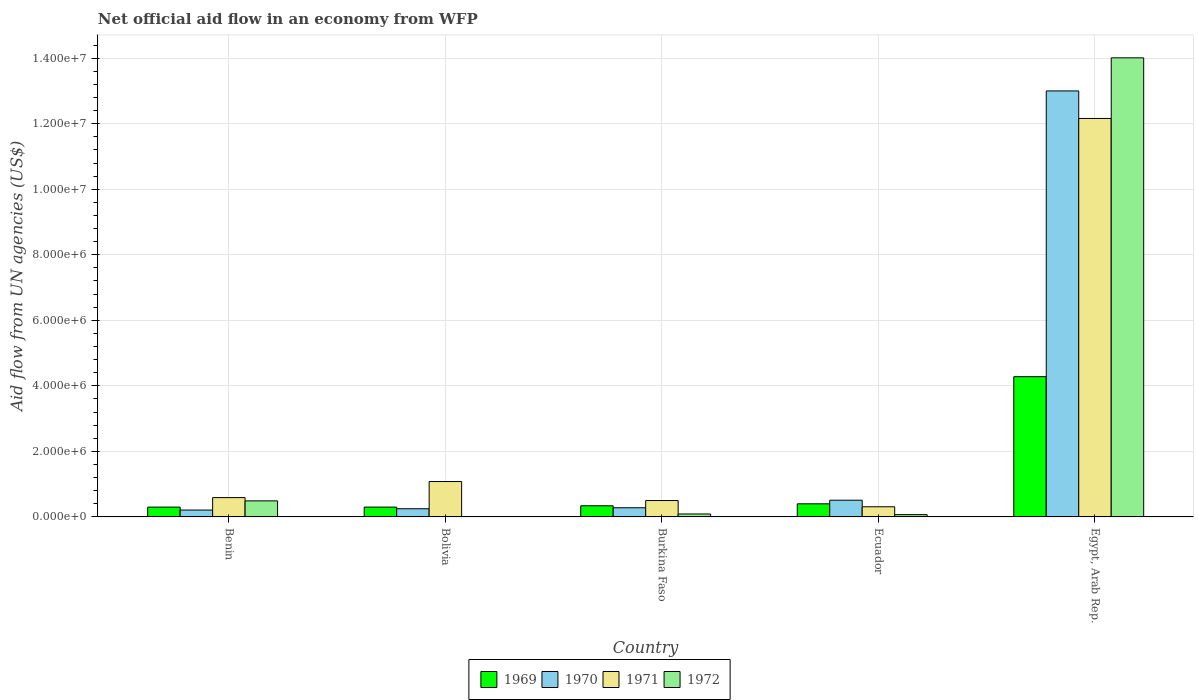How many groups of bars are there?
Provide a succinct answer. 5. Are the number of bars per tick equal to the number of legend labels?
Offer a very short reply. No. Are the number of bars on each tick of the X-axis equal?
Make the answer very short. No. How many bars are there on the 5th tick from the left?
Your answer should be very brief. 4. What is the label of the 5th group of bars from the left?
Keep it short and to the point. Egypt, Arab Rep. What is the net official aid flow in 1972 in Bolivia?
Your answer should be very brief. 0. Across all countries, what is the maximum net official aid flow in 1971?
Your answer should be very brief. 1.22e+07. In which country was the net official aid flow in 1971 maximum?
Ensure brevity in your answer.  Egypt, Arab Rep. What is the total net official aid flow in 1970 in the graph?
Offer a terse response. 1.42e+07. What is the difference between the net official aid flow in 1971 in Benin and that in Burkina Faso?
Provide a short and direct response. 9.00e+04. What is the average net official aid flow in 1972 per country?
Make the answer very short. 2.93e+06. What is the difference between the net official aid flow of/in 1971 and net official aid flow of/in 1969 in Burkina Faso?
Keep it short and to the point. 1.60e+05. What is the ratio of the net official aid flow in 1972 in Benin to that in Burkina Faso?
Provide a short and direct response. 5.44. Is the net official aid flow in 1972 in Benin less than that in Egypt, Arab Rep.?
Your answer should be compact. Yes. Is the difference between the net official aid flow in 1971 in Bolivia and Egypt, Arab Rep. greater than the difference between the net official aid flow in 1969 in Bolivia and Egypt, Arab Rep.?
Your response must be concise. No. What is the difference between the highest and the second highest net official aid flow in 1970?
Provide a succinct answer. 1.25e+07. What is the difference between the highest and the lowest net official aid flow in 1972?
Provide a succinct answer. 1.40e+07. Is the sum of the net official aid flow in 1969 in Benin and Egypt, Arab Rep. greater than the maximum net official aid flow in 1971 across all countries?
Provide a succinct answer. No. Is it the case that in every country, the sum of the net official aid flow in 1971 and net official aid flow in 1970 is greater than the sum of net official aid flow in 1969 and net official aid flow in 1972?
Offer a terse response. No. Is it the case that in every country, the sum of the net official aid flow in 1971 and net official aid flow in 1969 is greater than the net official aid flow in 1972?
Your answer should be very brief. Yes. How many bars are there?
Ensure brevity in your answer.  19. How many countries are there in the graph?
Offer a very short reply. 5. Are the values on the major ticks of Y-axis written in scientific E-notation?
Ensure brevity in your answer.  Yes. Where does the legend appear in the graph?
Offer a terse response. Bottom center. How are the legend labels stacked?
Your answer should be very brief. Horizontal. What is the title of the graph?
Your answer should be very brief. Net official aid flow in an economy from WFP. What is the label or title of the Y-axis?
Give a very brief answer. Aid flow from UN agencies (US$). What is the Aid flow from UN agencies (US$) of 1969 in Benin?
Offer a terse response. 3.00e+05. What is the Aid flow from UN agencies (US$) in 1970 in Benin?
Your response must be concise. 2.10e+05. What is the Aid flow from UN agencies (US$) of 1971 in Benin?
Make the answer very short. 5.90e+05. What is the Aid flow from UN agencies (US$) of 1972 in Benin?
Give a very brief answer. 4.90e+05. What is the Aid flow from UN agencies (US$) of 1969 in Bolivia?
Give a very brief answer. 3.00e+05. What is the Aid flow from UN agencies (US$) of 1971 in Bolivia?
Offer a very short reply. 1.08e+06. What is the Aid flow from UN agencies (US$) of 1972 in Bolivia?
Keep it short and to the point. 0. What is the Aid flow from UN agencies (US$) of 1969 in Burkina Faso?
Give a very brief answer. 3.40e+05. What is the Aid flow from UN agencies (US$) in 1970 in Burkina Faso?
Ensure brevity in your answer.  2.80e+05. What is the Aid flow from UN agencies (US$) in 1972 in Burkina Faso?
Give a very brief answer. 9.00e+04. What is the Aid flow from UN agencies (US$) of 1969 in Ecuador?
Give a very brief answer. 4.00e+05. What is the Aid flow from UN agencies (US$) of 1970 in Ecuador?
Offer a terse response. 5.10e+05. What is the Aid flow from UN agencies (US$) in 1971 in Ecuador?
Your response must be concise. 3.10e+05. What is the Aid flow from UN agencies (US$) of 1972 in Ecuador?
Provide a short and direct response. 7.00e+04. What is the Aid flow from UN agencies (US$) in 1969 in Egypt, Arab Rep.?
Make the answer very short. 4.28e+06. What is the Aid flow from UN agencies (US$) in 1970 in Egypt, Arab Rep.?
Make the answer very short. 1.30e+07. What is the Aid flow from UN agencies (US$) of 1971 in Egypt, Arab Rep.?
Your response must be concise. 1.22e+07. What is the Aid flow from UN agencies (US$) of 1972 in Egypt, Arab Rep.?
Give a very brief answer. 1.40e+07. Across all countries, what is the maximum Aid flow from UN agencies (US$) in 1969?
Ensure brevity in your answer.  4.28e+06. Across all countries, what is the maximum Aid flow from UN agencies (US$) of 1970?
Provide a short and direct response. 1.30e+07. Across all countries, what is the maximum Aid flow from UN agencies (US$) in 1971?
Offer a very short reply. 1.22e+07. Across all countries, what is the maximum Aid flow from UN agencies (US$) of 1972?
Provide a succinct answer. 1.40e+07. Across all countries, what is the minimum Aid flow from UN agencies (US$) in 1972?
Ensure brevity in your answer.  0. What is the total Aid flow from UN agencies (US$) of 1969 in the graph?
Provide a short and direct response. 5.62e+06. What is the total Aid flow from UN agencies (US$) in 1970 in the graph?
Ensure brevity in your answer.  1.42e+07. What is the total Aid flow from UN agencies (US$) of 1971 in the graph?
Your response must be concise. 1.46e+07. What is the total Aid flow from UN agencies (US$) of 1972 in the graph?
Offer a terse response. 1.47e+07. What is the difference between the Aid flow from UN agencies (US$) in 1971 in Benin and that in Bolivia?
Offer a terse response. -4.90e+05. What is the difference between the Aid flow from UN agencies (US$) of 1969 in Benin and that in Burkina Faso?
Offer a very short reply. -4.00e+04. What is the difference between the Aid flow from UN agencies (US$) in 1971 in Benin and that in Burkina Faso?
Ensure brevity in your answer.  9.00e+04. What is the difference between the Aid flow from UN agencies (US$) of 1972 in Benin and that in Burkina Faso?
Give a very brief answer. 4.00e+05. What is the difference between the Aid flow from UN agencies (US$) in 1969 in Benin and that in Egypt, Arab Rep.?
Your answer should be very brief. -3.98e+06. What is the difference between the Aid flow from UN agencies (US$) in 1970 in Benin and that in Egypt, Arab Rep.?
Give a very brief answer. -1.28e+07. What is the difference between the Aid flow from UN agencies (US$) of 1971 in Benin and that in Egypt, Arab Rep.?
Provide a short and direct response. -1.16e+07. What is the difference between the Aid flow from UN agencies (US$) of 1972 in Benin and that in Egypt, Arab Rep.?
Provide a short and direct response. -1.35e+07. What is the difference between the Aid flow from UN agencies (US$) of 1969 in Bolivia and that in Burkina Faso?
Your answer should be very brief. -4.00e+04. What is the difference between the Aid flow from UN agencies (US$) of 1971 in Bolivia and that in Burkina Faso?
Provide a succinct answer. 5.80e+05. What is the difference between the Aid flow from UN agencies (US$) in 1969 in Bolivia and that in Ecuador?
Your answer should be compact. -1.00e+05. What is the difference between the Aid flow from UN agencies (US$) in 1970 in Bolivia and that in Ecuador?
Provide a short and direct response. -2.60e+05. What is the difference between the Aid flow from UN agencies (US$) in 1971 in Bolivia and that in Ecuador?
Make the answer very short. 7.70e+05. What is the difference between the Aid flow from UN agencies (US$) in 1969 in Bolivia and that in Egypt, Arab Rep.?
Provide a short and direct response. -3.98e+06. What is the difference between the Aid flow from UN agencies (US$) of 1970 in Bolivia and that in Egypt, Arab Rep.?
Provide a succinct answer. -1.28e+07. What is the difference between the Aid flow from UN agencies (US$) of 1971 in Bolivia and that in Egypt, Arab Rep.?
Offer a very short reply. -1.11e+07. What is the difference between the Aid flow from UN agencies (US$) of 1970 in Burkina Faso and that in Ecuador?
Ensure brevity in your answer.  -2.30e+05. What is the difference between the Aid flow from UN agencies (US$) in 1971 in Burkina Faso and that in Ecuador?
Keep it short and to the point. 1.90e+05. What is the difference between the Aid flow from UN agencies (US$) of 1972 in Burkina Faso and that in Ecuador?
Ensure brevity in your answer.  2.00e+04. What is the difference between the Aid flow from UN agencies (US$) in 1969 in Burkina Faso and that in Egypt, Arab Rep.?
Your response must be concise. -3.94e+06. What is the difference between the Aid flow from UN agencies (US$) in 1970 in Burkina Faso and that in Egypt, Arab Rep.?
Provide a short and direct response. -1.27e+07. What is the difference between the Aid flow from UN agencies (US$) in 1971 in Burkina Faso and that in Egypt, Arab Rep.?
Give a very brief answer. -1.17e+07. What is the difference between the Aid flow from UN agencies (US$) of 1972 in Burkina Faso and that in Egypt, Arab Rep.?
Your answer should be very brief. -1.39e+07. What is the difference between the Aid flow from UN agencies (US$) of 1969 in Ecuador and that in Egypt, Arab Rep.?
Provide a short and direct response. -3.88e+06. What is the difference between the Aid flow from UN agencies (US$) in 1970 in Ecuador and that in Egypt, Arab Rep.?
Offer a terse response. -1.25e+07. What is the difference between the Aid flow from UN agencies (US$) of 1971 in Ecuador and that in Egypt, Arab Rep.?
Your answer should be very brief. -1.18e+07. What is the difference between the Aid flow from UN agencies (US$) in 1972 in Ecuador and that in Egypt, Arab Rep.?
Provide a short and direct response. -1.39e+07. What is the difference between the Aid flow from UN agencies (US$) of 1969 in Benin and the Aid flow from UN agencies (US$) of 1970 in Bolivia?
Your response must be concise. 5.00e+04. What is the difference between the Aid flow from UN agencies (US$) of 1969 in Benin and the Aid flow from UN agencies (US$) of 1971 in Bolivia?
Provide a succinct answer. -7.80e+05. What is the difference between the Aid flow from UN agencies (US$) in 1970 in Benin and the Aid flow from UN agencies (US$) in 1971 in Bolivia?
Your response must be concise. -8.70e+05. What is the difference between the Aid flow from UN agencies (US$) of 1969 in Benin and the Aid flow from UN agencies (US$) of 1971 in Burkina Faso?
Your answer should be compact. -2.00e+05. What is the difference between the Aid flow from UN agencies (US$) of 1970 in Benin and the Aid flow from UN agencies (US$) of 1971 in Burkina Faso?
Ensure brevity in your answer.  -2.90e+05. What is the difference between the Aid flow from UN agencies (US$) in 1971 in Benin and the Aid flow from UN agencies (US$) in 1972 in Burkina Faso?
Ensure brevity in your answer.  5.00e+05. What is the difference between the Aid flow from UN agencies (US$) in 1969 in Benin and the Aid flow from UN agencies (US$) in 1970 in Ecuador?
Offer a very short reply. -2.10e+05. What is the difference between the Aid flow from UN agencies (US$) in 1970 in Benin and the Aid flow from UN agencies (US$) in 1972 in Ecuador?
Make the answer very short. 1.40e+05. What is the difference between the Aid flow from UN agencies (US$) of 1971 in Benin and the Aid flow from UN agencies (US$) of 1972 in Ecuador?
Keep it short and to the point. 5.20e+05. What is the difference between the Aid flow from UN agencies (US$) in 1969 in Benin and the Aid flow from UN agencies (US$) in 1970 in Egypt, Arab Rep.?
Your answer should be very brief. -1.27e+07. What is the difference between the Aid flow from UN agencies (US$) in 1969 in Benin and the Aid flow from UN agencies (US$) in 1971 in Egypt, Arab Rep.?
Offer a terse response. -1.19e+07. What is the difference between the Aid flow from UN agencies (US$) of 1969 in Benin and the Aid flow from UN agencies (US$) of 1972 in Egypt, Arab Rep.?
Offer a very short reply. -1.37e+07. What is the difference between the Aid flow from UN agencies (US$) in 1970 in Benin and the Aid flow from UN agencies (US$) in 1971 in Egypt, Arab Rep.?
Make the answer very short. -1.20e+07. What is the difference between the Aid flow from UN agencies (US$) of 1970 in Benin and the Aid flow from UN agencies (US$) of 1972 in Egypt, Arab Rep.?
Offer a terse response. -1.38e+07. What is the difference between the Aid flow from UN agencies (US$) of 1971 in Benin and the Aid flow from UN agencies (US$) of 1972 in Egypt, Arab Rep.?
Provide a succinct answer. -1.34e+07. What is the difference between the Aid flow from UN agencies (US$) of 1969 in Bolivia and the Aid flow from UN agencies (US$) of 1971 in Burkina Faso?
Keep it short and to the point. -2.00e+05. What is the difference between the Aid flow from UN agencies (US$) of 1970 in Bolivia and the Aid flow from UN agencies (US$) of 1972 in Burkina Faso?
Offer a very short reply. 1.60e+05. What is the difference between the Aid flow from UN agencies (US$) of 1971 in Bolivia and the Aid flow from UN agencies (US$) of 1972 in Burkina Faso?
Keep it short and to the point. 9.90e+05. What is the difference between the Aid flow from UN agencies (US$) of 1969 in Bolivia and the Aid flow from UN agencies (US$) of 1972 in Ecuador?
Give a very brief answer. 2.30e+05. What is the difference between the Aid flow from UN agencies (US$) of 1970 in Bolivia and the Aid flow from UN agencies (US$) of 1972 in Ecuador?
Make the answer very short. 1.80e+05. What is the difference between the Aid flow from UN agencies (US$) of 1971 in Bolivia and the Aid flow from UN agencies (US$) of 1972 in Ecuador?
Make the answer very short. 1.01e+06. What is the difference between the Aid flow from UN agencies (US$) in 1969 in Bolivia and the Aid flow from UN agencies (US$) in 1970 in Egypt, Arab Rep.?
Ensure brevity in your answer.  -1.27e+07. What is the difference between the Aid flow from UN agencies (US$) of 1969 in Bolivia and the Aid flow from UN agencies (US$) of 1971 in Egypt, Arab Rep.?
Offer a very short reply. -1.19e+07. What is the difference between the Aid flow from UN agencies (US$) of 1969 in Bolivia and the Aid flow from UN agencies (US$) of 1972 in Egypt, Arab Rep.?
Your answer should be compact. -1.37e+07. What is the difference between the Aid flow from UN agencies (US$) of 1970 in Bolivia and the Aid flow from UN agencies (US$) of 1971 in Egypt, Arab Rep.?
Ensure brevity in your answer.  -1.19e+07. What is the difference between the Aid flow from UN agencies (US$) in 1970 in Bolivia and the Aid flow from UN agencies (US$) in 1972 in Egypt, Arab Rep.?
Make the answer very short. -1.38e+07. What is the difference between the Aid flow from UN agencies (US$) of 1971 in Bolivia and the Aid flow from UN agencies (US$) of 1972 in Egypt, Arab Rep.?
Your answer should be compact. -1.29e+07. What is the difference between the Aid flow from UN agencies (US$) in 1969 in Burkina Faso and the Aid flow from UN agencies (US$) in 1970 in Ecuador?
Provide a succinct answer. -1.70e+05. What is the difference between the Aid flow from UN agencies (US$) of 1969 in Burkina Faso and the Aid flow from UN agencies (US$) of 1972 in Ecuador?
Ensure brevity in your answer.  2.70e+05. What is the difference between the Aid flow from UN agencies (US$) in 1970 in Burkina Faso and the Aid flow from UN agencies (US$) in 1971 in Ecuador?
Make the answer very short. -3.00e+04. What is the difference between the Aid flow from UN agencies (US$) of 1971 in Burkina Faso and the Aid flow from UN agencies (US$) of 1972 in Ecuador?
Offer a very short reply. 4.30e+05. What is the difference between the Aid flow from UN agencies (US$) of 1969 in Burkina Faso and the Aid flow from UN agencies (US$) of 1970 in Egypt, Arab Rep.?
Offer a very short reply. -1.27e+07. What is the difference between the Aid flow from UN agencies (US$) in 1969 in Burkina Faso and the Aid flow from UN agencies (US$) in 1971 in Egypt, Arab Rep.?
Your response must be concise. -1.18e+07. What is the difference between the Aid flow from UN agencies (US$) of 1969 in Burkina Faso and the Aid flow from UN agencies (US$) of 1972 in Egypt, Arab Rep.?
Give a very brief answer. -1.37e+07. What is the difference between the Aid flow from UN agencies (US$) in 1970 in Burkina Faso and the Aid flow from UN agencies (US$) in 1971 in Egypt, Arab Rep.?
Ensure brevity in your answer.  -1.19e+07. What is the difference between the Aid flow from UN agencies (US$) in 1970 in Burkina Faso and the Aid flow from UN agencies (US$) in 1972 in Egypt, Arab Rep.?
Ensure brevity in your answer.  -1.37e+07. What is the difference between the Aid flow from UN agencies (US$) of 1971 in Burkina Faso and the Aid flow from UN agencies (US$) of 1972 in Egypt, Arab Rep.?
Your response must be concise. -1.35e+07. What is the difference between the Aid flow from UN agencies (US$) in 1969 in Ecuador and the Aid flow from UN agencies (US$) in 1970 in Egypt, Arab Rep.?
Your response must be concise. -1.26e+07. What is the difference between the Aid flow from UN agencies (US$) of 1969 in Ecuador and the Aid flow from UN agencies (US$) of 1971 in Egypt, Arab Rep.?
Your answer should be very brief. -1.18e+07. What is the difference between the Aid flow from UN agencies (US$) in 1969 in Ecuador and the Aid flow from UN agencies (US$) in 1972 in Egypt, Arab Rep.?
Your answer should be compact. -1.36e+07. What is the difference between the Aid flow from UN agencies (US$) of 1970 in Ecuador and the Aid flow from UN agencies (US$) of 1971 in Egypt, Arab Rep.?
Make the answer very short. -1.16e+07. What is the difference between the Aid flow from UN agencies (US$) of 1970 in Ecuador and the Aid flow from UN agencies (US$) of 1972 in Egypt, Arab Rep.?
Make the answer very short. -1.35e+07. What is the difference between the Aid flow from UN agencies (US$) of 1971 in Ecuador and the Aid flow from UN agencies (US$) of 1972 in Egypt, Arab Rep.?
Provide a succinct answer. -1.37e+07. What is the average Aid flow from UN agencies (US$) in 1969 per country?
Your answer should be compact. 1.12e+06. What is the average Aid flow from UN agencies (US$) in 1970 per country?
Your response must be concise. 2.85e+06. What is the average Aid flow from UN agencies (US$) in 1971 per country?
Your answer should be very brief. 2.93e+06. What is the average Aid flow from UN agencies (US$) of 1972 per country?
Your answer should be very brief. 2.93e+06. What is the difference between the Aid flow from UN agencies (US$) of 1969 and Aid flow from UN agencies (US$) of 1970 in Benin?
Your response must be concise. 9.00e+04. What is the difference between the Aid flow from UN agencies (US$) of 1970 and Aid flow from UN agencies (US$) of 1971 in Benin?
Make the answer very short. -3.80e+05. What is the difference between the Aid flow from UN agencies (US$) of 1970 and Aid flow from UN agencies (US$) of 1972 in Benin?
Keep it short and to the point. -2.80e+05. What is the difference between the Aid flow from UN agencies (US$) of 1969 and Aid flow from UN agencies (US$) of 1971 in Bolivia?
Offer a very short reply. -7.80e+05. What is the difference between the Aid flow from UN agencies (US$) in 1970 and Aid flow from UN agencies (US$) in 1971 in Bolivia?
Your answer should be compact. -8.30e+05. What is the difference between the Aid flow from UN agencies (US$) in 1969 and Aid flow from UN agencies (US$) in 1970 in Burkina Faso?
Your response must be concise. 6.00e+04. What is the difference between the Aid flow from UN agencies (US$) of 1969 and Aid flow from UN agencies (US$) of 1972 in Burkina Faso?
Your answer should be compact. 2.50e+05. What is the difference between the Aid flow from UN agencies (US$) in 1970 and Aid flow from UN agencies (US$) in 1971 in Burkina Faso?
Offer a terse response. -2.20e+05. What is the difference between the Aid flow from UN agencies (US$) of 1970 and Aid flow from UN agencies (US$) of 1972 in Burkina Faso?
Provide a succinct answer. 1.90e+05. What is the difference between the Aid flow from UN agencies (US$) in 1970 and Aid flow from UN agencies (US$) in 1971 in Ecuador?
Your answer should be compact. 2.00e+05. What is the difference between the Aid flow from UN agencies (US$) in 1969 and Aid flow from UN agencies (US$) in 1970 in Egypt, Arab Rep.?
Give a very brief answer. -8.72e+06. What is the difference between the Aid flow from UN agencies (US$) in 1969 and Aid flow from UN agencies (US$) in 1971 in Egypt, Arab Rep.?
Give a very brief answer. -7.88e+06. What is the difference between the Aid flow from UN agencies (US$) in 1969 and Aid flow from UN agencies (US$) in 1972 in Egypt, Arab Rep.?
Your answer should be very brief. -9.73e+06. What is the difference between the Aid flow from UN agencies (US$) in 1970 and Aid flow from UN agencies (US$) in 1971 in Egypt, Arab Rep.?
Give a very brief answer. 8.40e+05. What is the difference between the Aid flow from UN agencies (US$) of 1970 and Aid flow from UN agencies (US$) of 1972 in Egypt, Arab Rep.?
Your answer should be compact. -1.01e+06. What is the difference between the Aid flow from UN agencies (US$) in 1971 and Aid flow from UN agencies (US$) in 1972 in Egypt, Arab Rep.?
Provide a succinct answer. -1.85e+06. What is the ratio of the Aid flow from UN agencies (US$) in 1969 in Benin to that in Bolivia?
Your answer should be very brief. 1. What is the ratio of the Aid flow from UN agencies (US$) in 1970 in Benin to that in Bolivia?
Keep it short and to the point. 0.84. What is the ratio of the Aid flow from UN agencies (US$) of 1971 in Benin to that in Bolivia?
Give a very brief answer. 0.55. What is the ratio of the Aid flow from UN agencies (US$) of 1969 in Benin to that in Burkina Faso?
Offer a terse response. 0.88. What is the ratio of the Aid flow from UN agencies (US$) of 1970 in Benin to that in Burkina Faso?
Your answer should be compact. 0.75. What is the ratio of the Aid flow from UN agencies (US$) of 1971 in Benin to that in Burkina Faso?
Provide a short and direct response. 1.18. What is the ratio of the Aid flow from UN agencies (US$) of 1972 in Benin to that in Burkina Faso?
Keep it short and to the point. 5.44. What is the ratio of the Aid flow from UN agencies (US$) in 1969 in Benin to that in Ecuador?
Make the answer very short. 0.75. What is the ratio of the Aid flow from UN agencies (US$) in 1970 in Benin to that in Ecuador?
Your response must be concise. 0.41. What is the ratio of the Aid flow from UN agencies (US$) of 1971 in Benin to that in Ecuador?
Keep it short and to the point. 1.9. What is the ratio of the Aid flow from UN agencies (US$) of 1969 in Benin to that in Egypt, Arab Rep.?
Keep it short and to the point. 0.07. What is the ratio of the Aid flow from UN agencies (US$) of 1970 in Benin to that in Egypt, Arab Rep.?
Provide a succinct answer. 0.02. What is the ratio of the Aid flow from UN agencies (US$) of 1971 in Benin to that in Egypt, Arab Rep.?
Make the answer very short. 0.05. What is the ratio of the Aid flow from UN agencies (US$) of 1972 in Benin to that in Egypt, Arab Rep.?
Your answer should be very brief. 0.04. What is the ratio of the Aid flow from UN agencies (US$) in 1969 in Bolivia to that in Burkina Faso?
Your answer should be very brief. 0.88. What is the ratio of the Aid flow from UN agencies (US$) of 1970 in Bolivia to that in Burkina Faso?
Provide a short and direct response. 0.89. What is the ratio of the Aid flow from UN agencies (US$) in 1971 in Bolivia to that in Burkina Faso?
Provide a succinct answer. 2.16. What is the ratio of the Aid flow from UN agencies (US$) in 1970 in Bolivia to that in Ecuador?
Make the answer very short. 0.49. What is the ratio of the Aid flow from UN agencies (US$) in 1971 in Bolivia to that in Ecuador?
Provide a succinct answer. 3.48. What is the ratio of the Aid flow from UN agencies (US$) of 1969 in Bolivia to that in Egypt, Arab Rep.?
Provide a succinct answer. 0.07. What is the ratio of the Aid flow from UN agencies (US$) in 1970 in Bolivia to that in Egypt, Arab Rep.?
Give a very brief answer. 0.02. What is the ratio of the Aid flow from UN agencies (US$) in 1971 in Bolivia to that in Egypt, Arab Rep.?
Provide a succinct answer. 0.09. What is the ratio of the Aid flow from UN agencies (US$) of 1969 in Burkina Faso to that in Ecuador?
Offer a very short reply. 0.85. What is the ratio of the Aid flow from UN agencies (US$) of 1970 in Burkina Faso to that in Ecuador?
Your answer should be compact. 0.55. What is the ratio of the Aid flow from UN agencies (US$) in 1971 in Burkina Faso to that in Ecuador?
Give a very brief answer. 1.61. What is the ratio of the Aid flow from UN agencies (US$) of 1969 in Burkina Faso to that in Egypt, Arab Rep.?
Give a very brief answer. 0.08. What is the ratio of the Aid flow from UN agencies (US$) in 1970 in Burkina Faso to that in Egypt, Arab Rep.?
Ensure brevity in your answer.  0.02. What is the ratio of the Aid flow from UN agencies (US$) in 1971 in Burkina Faso to that in Egypt, Arab Rep.?
Keep it short and to the point. 0.04. What is the ratio of the Aid flow from UN agencies (US$) of 1972 in Burkina Faso to that in Egypt, Arab Rep.?
Offer a terse response. 0.01. What is the ratio of the Aid flow from UN agencies (US$) of 1969 in Ecuador to that in Egypt, Arab Rep.?
Keep it short and to the point. 0.09. What is the ratio of the Aid flow from UN agencies (US$) in 1970 in Ecuador to that in Egypt, Arab Rep.?
Offer a terse response. 0.04. What is the ratio of the Aid flow from UN agencies (US$) in 1971 in Ecuador to that in Egypt, Arab Rep.?
Offer a terse response. 0.03. What is the ratio of the Aid flow from UN agencies (US$) in 1972 in Ecuador to that in Egypt, Arab Rep.?
Offer a terse response. 0.01. What is the difference between the highest and the second highest Aid flow from UN agencies (US$) in 1969?
Your answer should be compact. 3.88e+06. What is the difference between the highest and the second highest Aid flow from UN agencies (US$) in 1970?
Ensure brevity in your answer.  1.25e+07. What is the difference between the highest and the second highest Aid flow from UN agencies (US$) of 1971?
Make the answer very short. 1.11e+07. What is the difference between the highest and the second highest Aid flow from UN agencies (US$) of 1972?
Ensure brevity in your answer.  1.35e+07. What is the difference between the highest and the lowest Aid flow from UN agencies (US$) in 1969?
Offer a terse response. 3.98e+06. What is the difference between the highest and the lowest Aid flow from UN agencies (US$) of 1970?
Provide a short and direct response. 1.28e+07. What is the difference between the highest and the lowest Aid flow from UN agencies (US$) of 1971?
Offer a terse response. 1.18e+07. What is the difference between the highest and the lowest Aid flow from UN agencies (US$) of 1972?
Make the answer very short. 1.40e+07. 